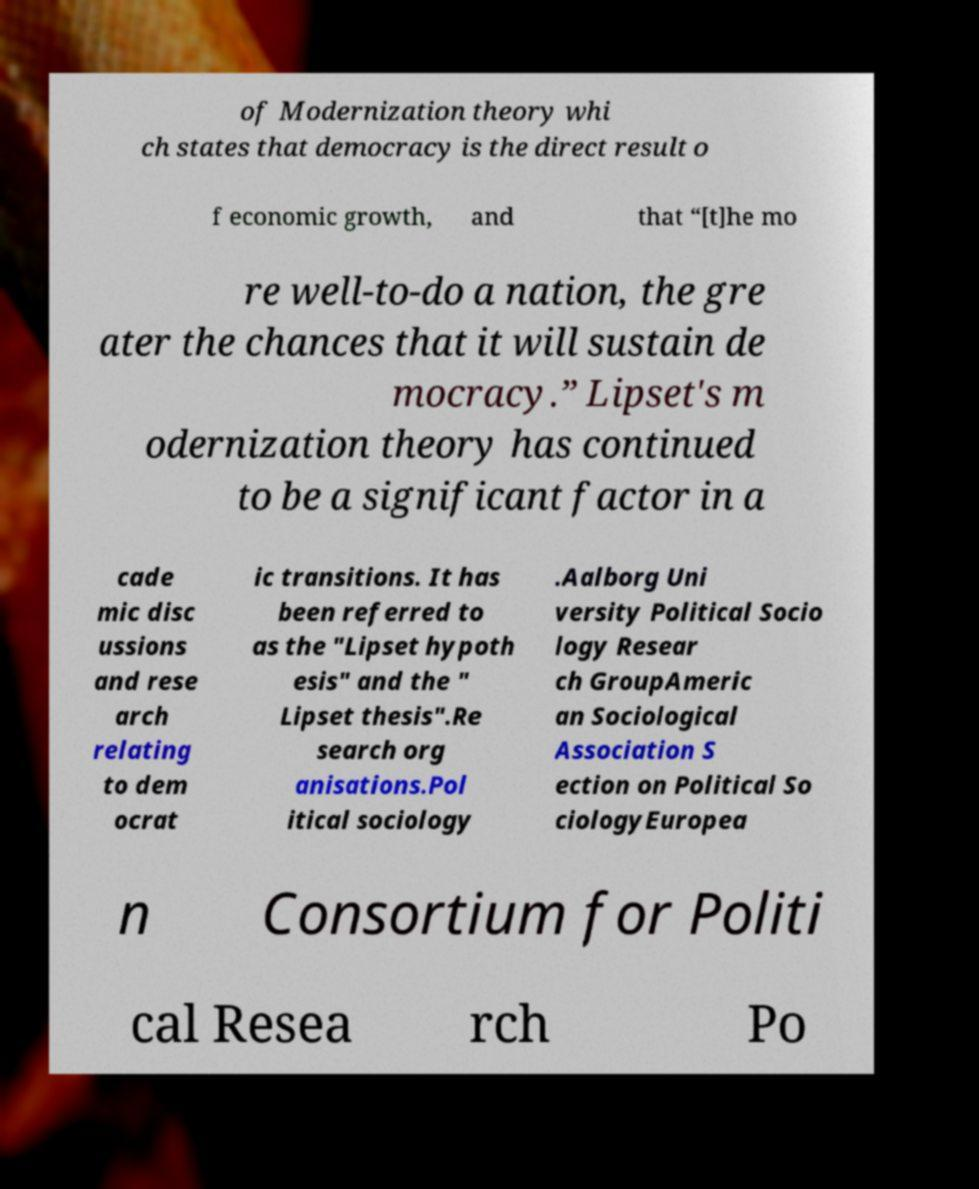What messages or text are displayed in this image? I need them in a readable, typed format. of Modernization theory whi ch states that democracy is the direct result o f economic growth, and that “[t]he mo re well-to-do a nation, the gre ater the chances that it will sustain de mocracy.” Lipset's m odernization theory has continued to be a significant factor in a cade mic disc ussions and rese arch relating to dem ocrat ic transitions. It has been referred to as the "Lipset hypoth esis" and the " Lipset thesis".Re search org anisations.Pol itical sociology .Aalborg Uni versity Political Socio logy Resear ch GroupAmeric an Sociological Association S ection on Political So ciologyEuropea n Consortium for Politi cal Resea rch Po 